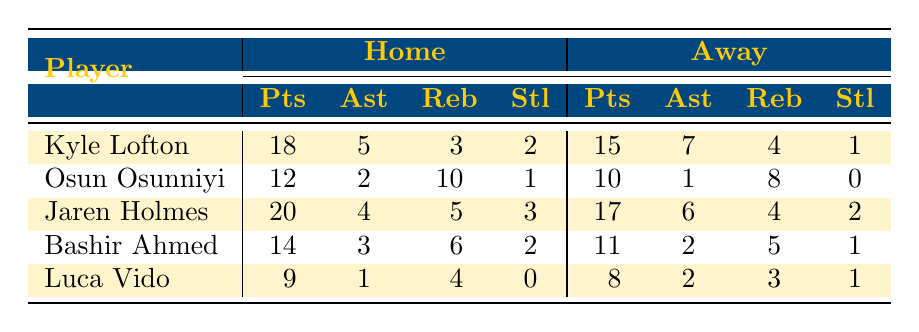What is the highest number of points scored by a player at home? In the "Home" column, I examine the Points scored by each player: Kyle Lofton scored 18, Osun Osunniyi scored 12, Jaren Holmes scored 20, Bashir Ahmed scored 14, and Luca Vido scored 9. The highest number is 20 by Jaren Holmes.
Answer: 20 What is the total number of assists made by Kyle Lofton in both home and away games? To find the total assists by Kyle Lofton, I add his home assists (5) to his away assists (7). 5 + 7 = 12.
Answer: 12 Did Osun Osunniyi steal the ball more often at home than away? At home, Osun Osunniyi had 1 steal, and away he had 0 steals. Since 1 is greater than 0, he stole the ball more often at home.
Answer: Yes What is the average number of rebounds for Jaren Holmes at home and away? I add Jaren Holmes' rebounds from home (5) and away (4), which totals 9 rebounds. I then divide this sum by 2 for the average: 9 / 2 = 4.5.
Answer: 4.5 Who had the most assists in away games? I look through the "Away" assists column: Kyle Lofton had 7, Osun Osunniyi had 1, Jaren Holmes had 6, Bashir Ahmed had 2, and Luca Vido had 2. The highest is 7 by Kyle Lofton.
Answer: Kyle Lofton What is the difference in points scored by Bashir Ahmed between home and away games? To find the difference, I take Bashir Ahmed's home points (14) and subtract his away points (11). 14 - 11 = 3.
Answer: 3 How many rebounds did Luca Vido grab in total throughout the season? I sum up Luca Vido's rebounds from home (4) and away (3): 4 + 3 = 7.
Answer: 7 Did Jaren Holmes score more points at home compared to away games? Jaren Holmes scored 20 points at home and 17 points away. Since 20 is greater than 17, he scored more at home.
Answer: Yes What is the total number of steals by all players in away games? I sum the steals from the "Away" column: Kyle Lofton (1) + Osun Osunniyi (0) + Jaren Holmes (2) + Bashir Ahmed (1) + Luca Vido (1) = 5.
Answer: 5 